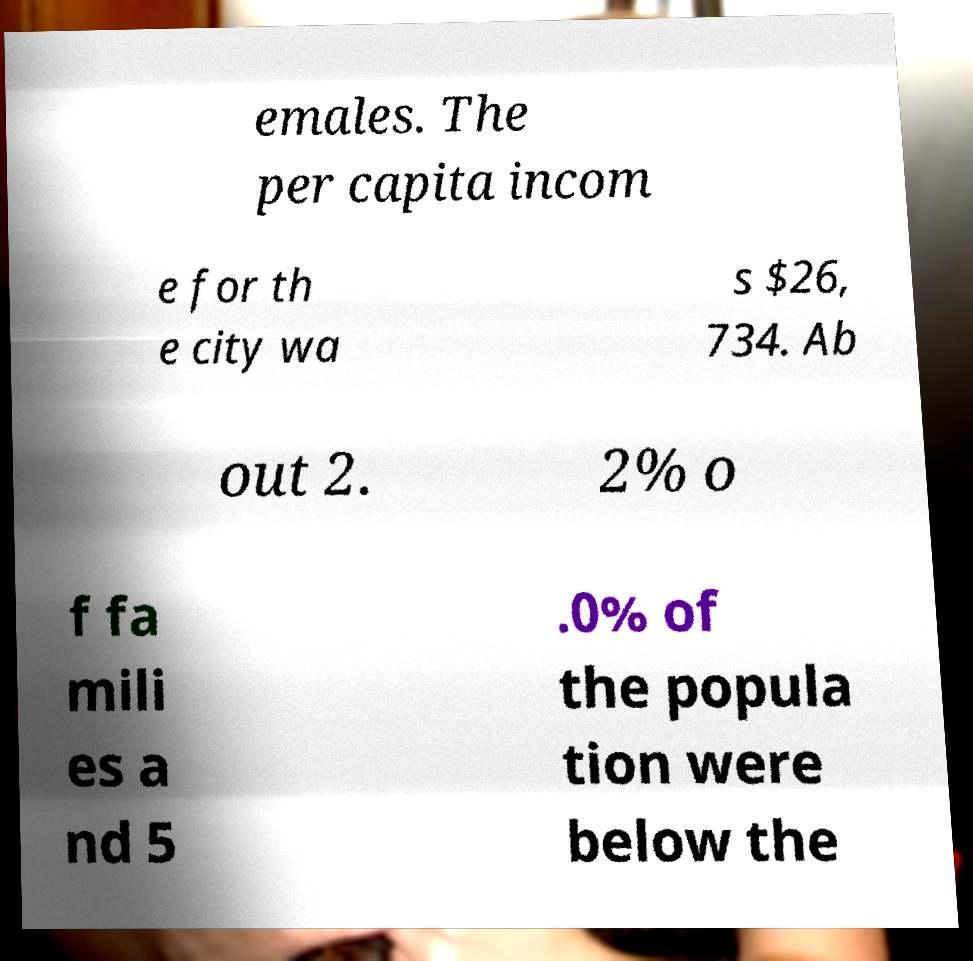Could you extract and type out the text from this image? emales. The per capita incom e for th e city wa s $26, 734. Ab out 2. 2% o f fa mili es a nd 5 .0% of the popula tion were below the 